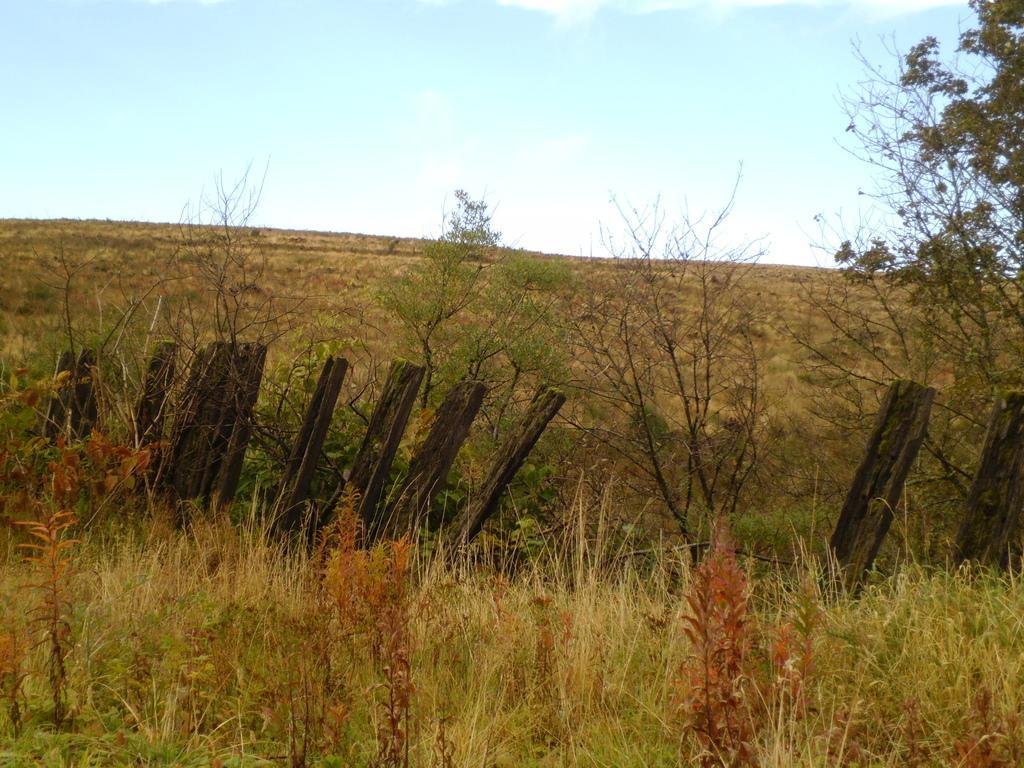Describe this image in one or two sentences. In this picture I can see green grass in the foreground. I can see trees. I can see fencing. I can see clouds in the sky. 